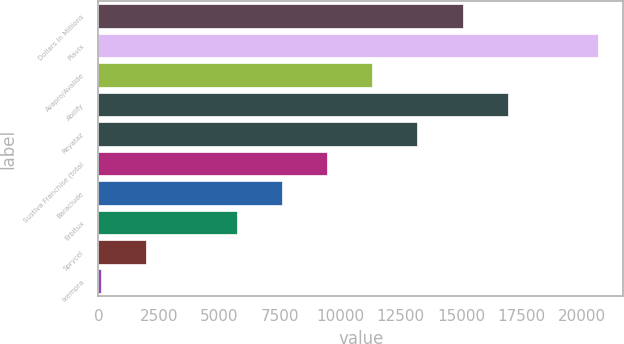<chart> <loc_0><loc_0><loc_500><loc_500><bar_chart><fcel>Dollars in Millions<fcel>Plavix<fcel>Avapro/Avalide<fcel>Abilify<fcel>Reyataz<fcel>Sustiva Franchise (total<fcel>Baraclude<fcel>Erbitux<fcel>Sprycel<fcel>Ixempra<nl><fcel>15068.2<fcel>20677.9<fcel>11328.4<fcel>16938.1<fcel>13198.3<fcel>9458.5<fcel>7588.6<fcel>5718.7<fcel>1978.9<fcel>109<nl></chart> 